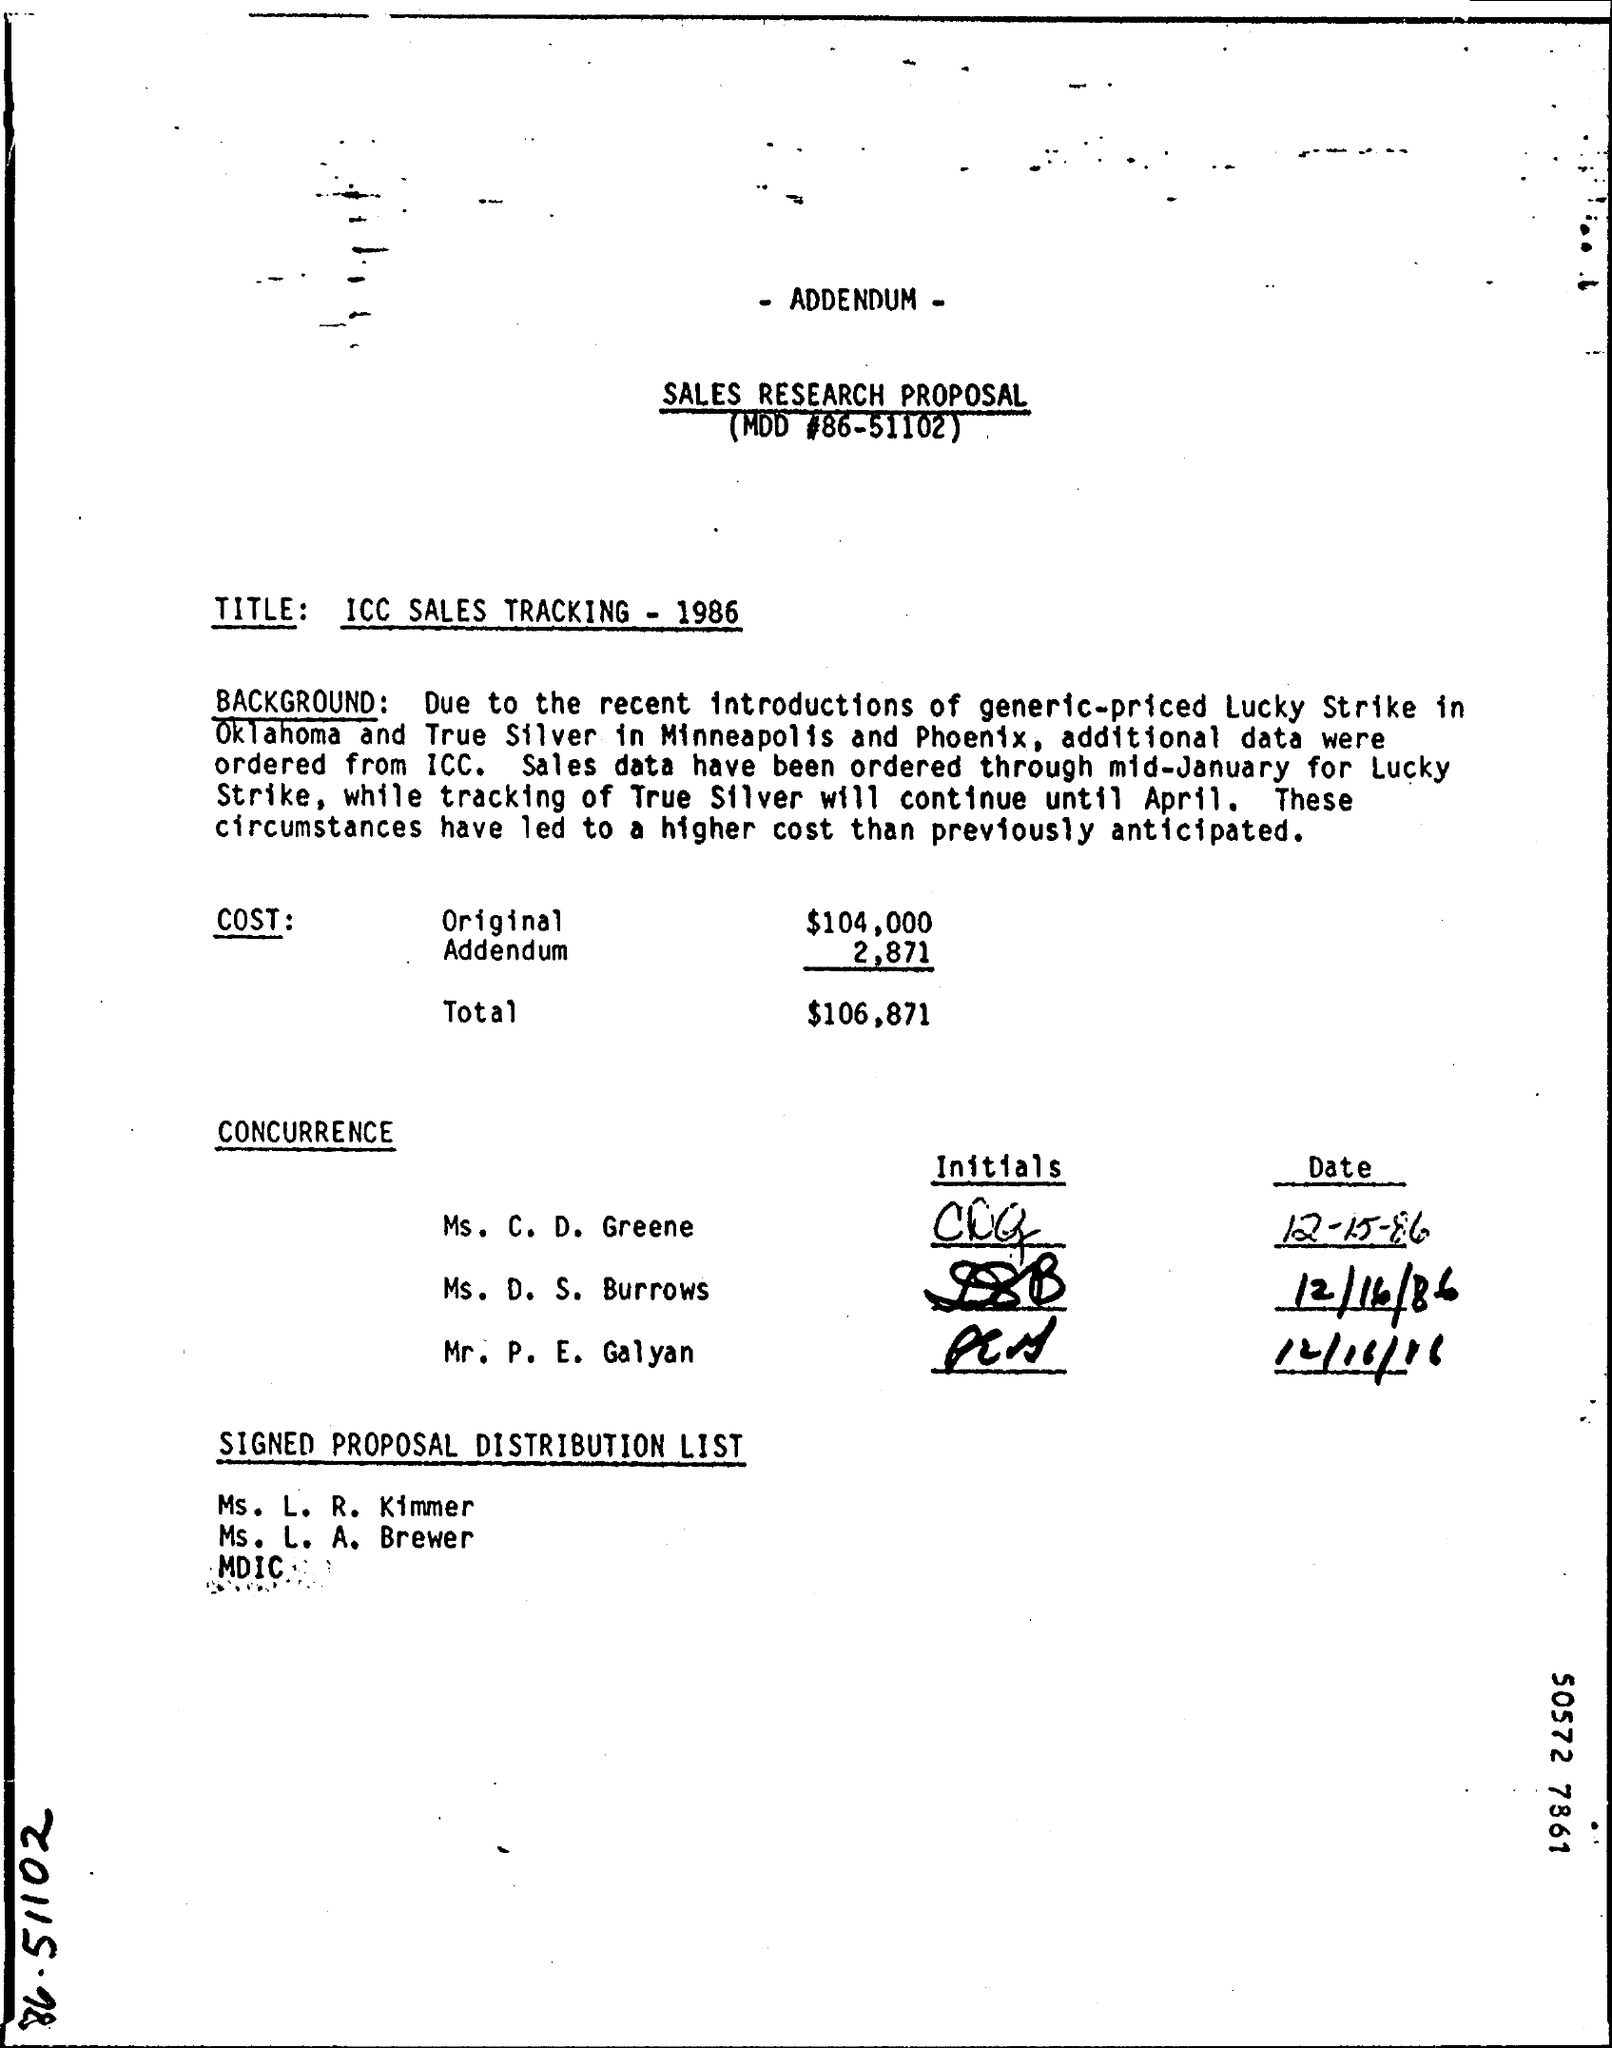What is the significance of the date mentioned in the document? The dates referenced in the document, such as February 25, 1986, likely indicate key administrative milestones or deadlines for the distribution of the sales proposal or the inclusion of additional data related to True Silver sales tracking. Could you explain who could be affected by these deadlines? The deadlines could affect multiple stakeholders, including the sales teams in Minneapolis and Phoenix, planning departments, and perhaps external suppliers who need to adjust their schedules according to the sales tracking outcomes and forecasts. 